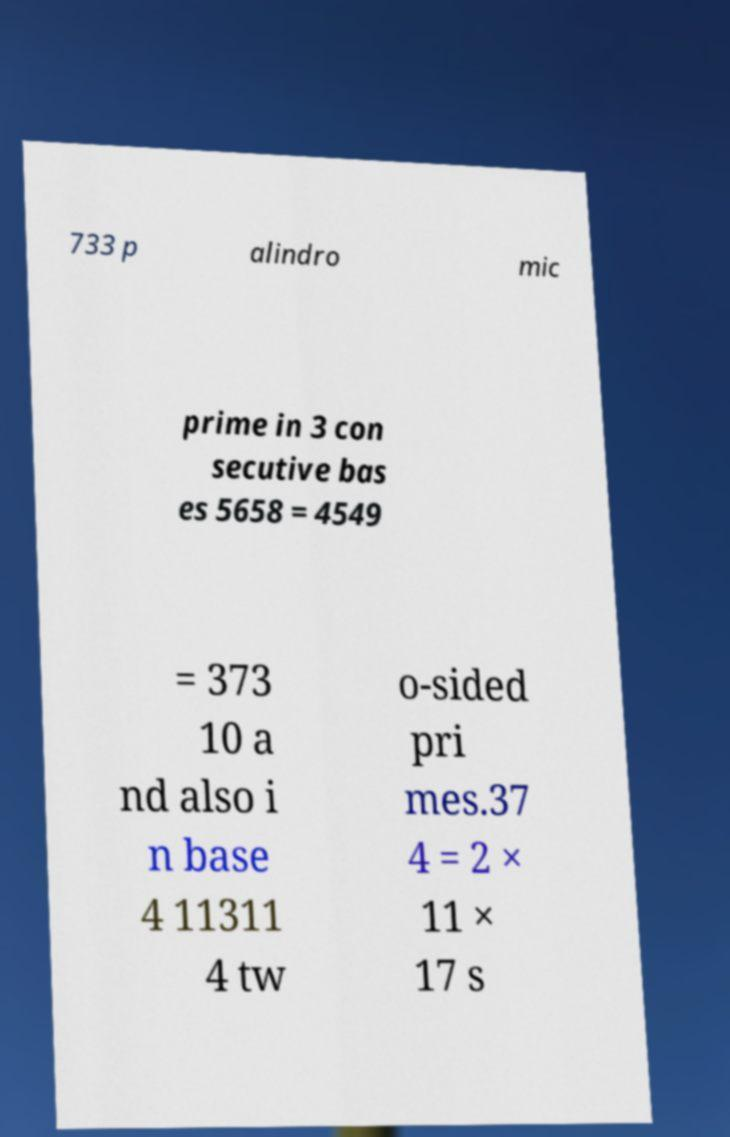What messages or text are displayed in this image? I need them in a readable, typed format. 733 p alindro mic prime in 3 con secutive bas es 5658 = 4549 = 373 10 a nd also i n base 4 11311 4 tw o-sided pri mes.37 4 = 2 × 11 × 17 s 